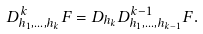<formula> <loc_0><loc_0><loc_500><loc_500>D _ { h _ { 1 } , \dots , h _ { k } } ^ { k } F = D _ { h _ { k } } D _ { h _ { 1 } , \dots , h _ { k - 1 } } ^ { k - 1 } F .</formula> 